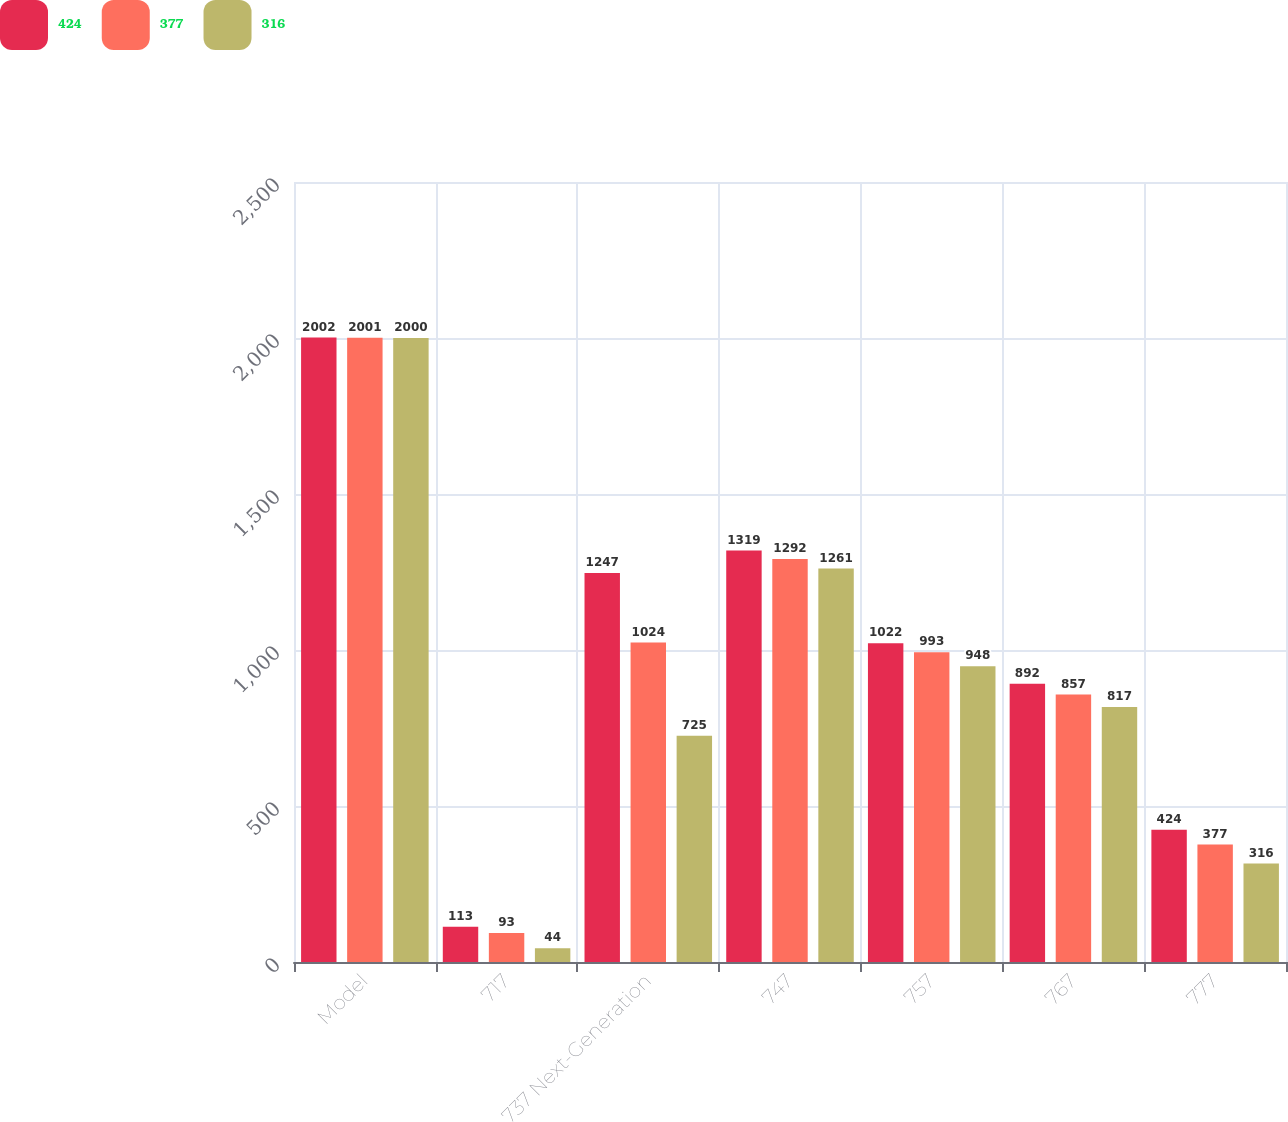<chart> <loc_0><loc_0><loc_500><loc_500><stacked_bar_chart><ecel><fcel>Model<fcel>717<fcel>737 Next-Generation<fcel>747<fcel>757<fcel>767<fcel>777<nl><fcel>424<fcel>2002<fcel>113<fcel>1247<fcel>1319<fcel>1022<fcel>892<fcel>424<nl><fcel>377<fcel>2001<fcel>93<fcel>1024<fcel>1292<fcel>993<fcel>857<fcel>377<nl><fcel>316<fcel>2000<fcel>44<fcel>725<fcel>1261<fcel>948<fcel>817<fcel>316<nl></chart> 